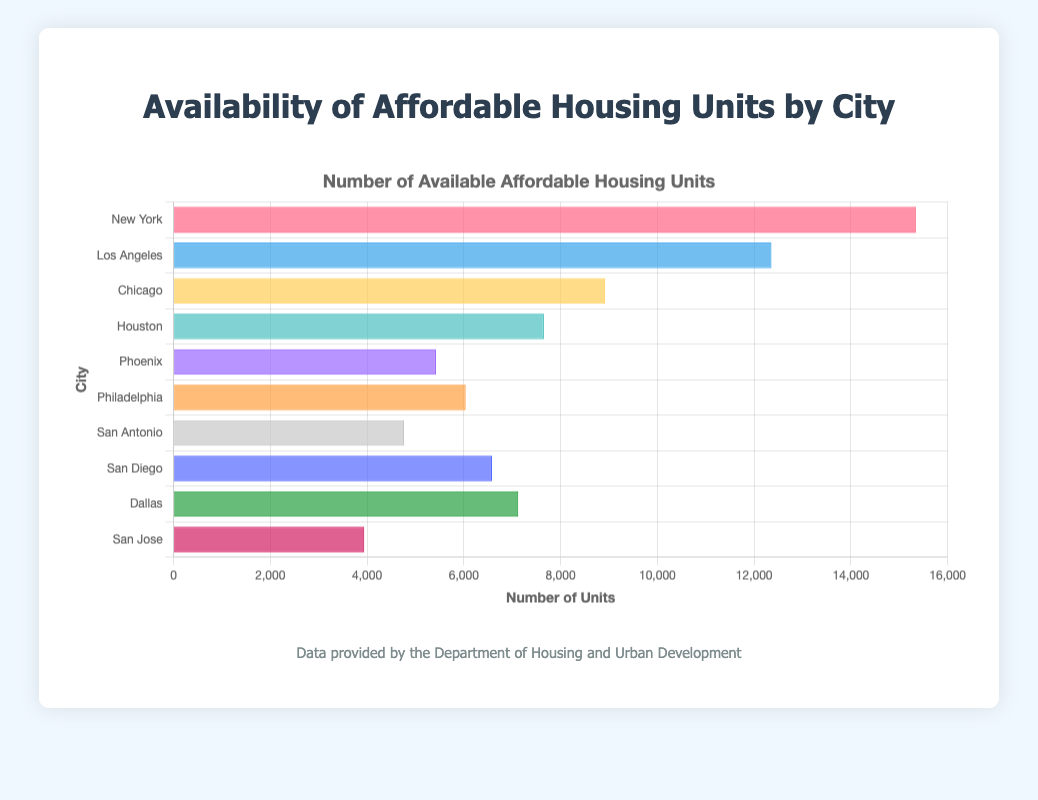Which city has the highest number of affordable housing units? The city with the highest bar represents the city with the highest number of affordable housing units. New York's bar is the longest.
Answer: New York How many available affordable housing units are there in San Diego? Find the height of the bar corresponding to San Diego. The bar for San Diego is labeled with 6581 units.
Answer: 6581 What is the total number of available affordable housing units for Philadelphia and Dallas combined? Add the units for Philadelphia (6038) and Dallas (7124). 6038 + 7124 = 13162
Answer: 13162 How many more affordable housing units does Chicago have compared to San Jose? Subtract the units for San Jose (3942) from the units for Chicago (8921). 8921 - 3942 = 4979
Answer: 4979 Which city has fewer affordable housing units, Phoenix or San Antonio? Compare the height of the bars for Phoenix and San Antonio. The bar for San Antonio is shorter with 4765 units compared to Phoenix's 5423 units.
Answer: San Antonio What is the average number of affordable housing units across all cities? Sum all the units (15342 + 12358 + 8921 + 7654 + 5423 + 6038 + 4765 + 6581 + 7124 + 3942) and divide by the number of cities (10). (15342 + 12358 + 8921 + 7654 + 5423 + 6038 + 4765 + 6581 + 7124 + 3942) / 10 = 8374.8
Answer: 8374.8 Which city has the least affordable housing units? Identify the shortest bar. The shortest bar is for San Jose with 3942 units.
Answer: San Jose How do the available units in Houston compare to those in Phoenix? Compare the height of the bars for Houston and Phoenix. Houston has 7654 units, which is higher than Phoenix's 5423 units.
Answer: Houston has more units What is the difference in affordable housing units between Los Angeles and Philadelphia? Subtract the units for Philadelphia (6038) from Los Angeles (12358). 12358 - 6038 = 6320
Answer: 6320 Which city has nearly half the number of units as New York? Identify the city whose bar is approximately half the height of New York's bar (15342). Los Angeles has about 12358 units which are not half, but Chicago has 8921, which is closer. 15342 / 2 = 7671, and none of the cities have exactly half, but Chicago is the closest.
Answer: Chicago 